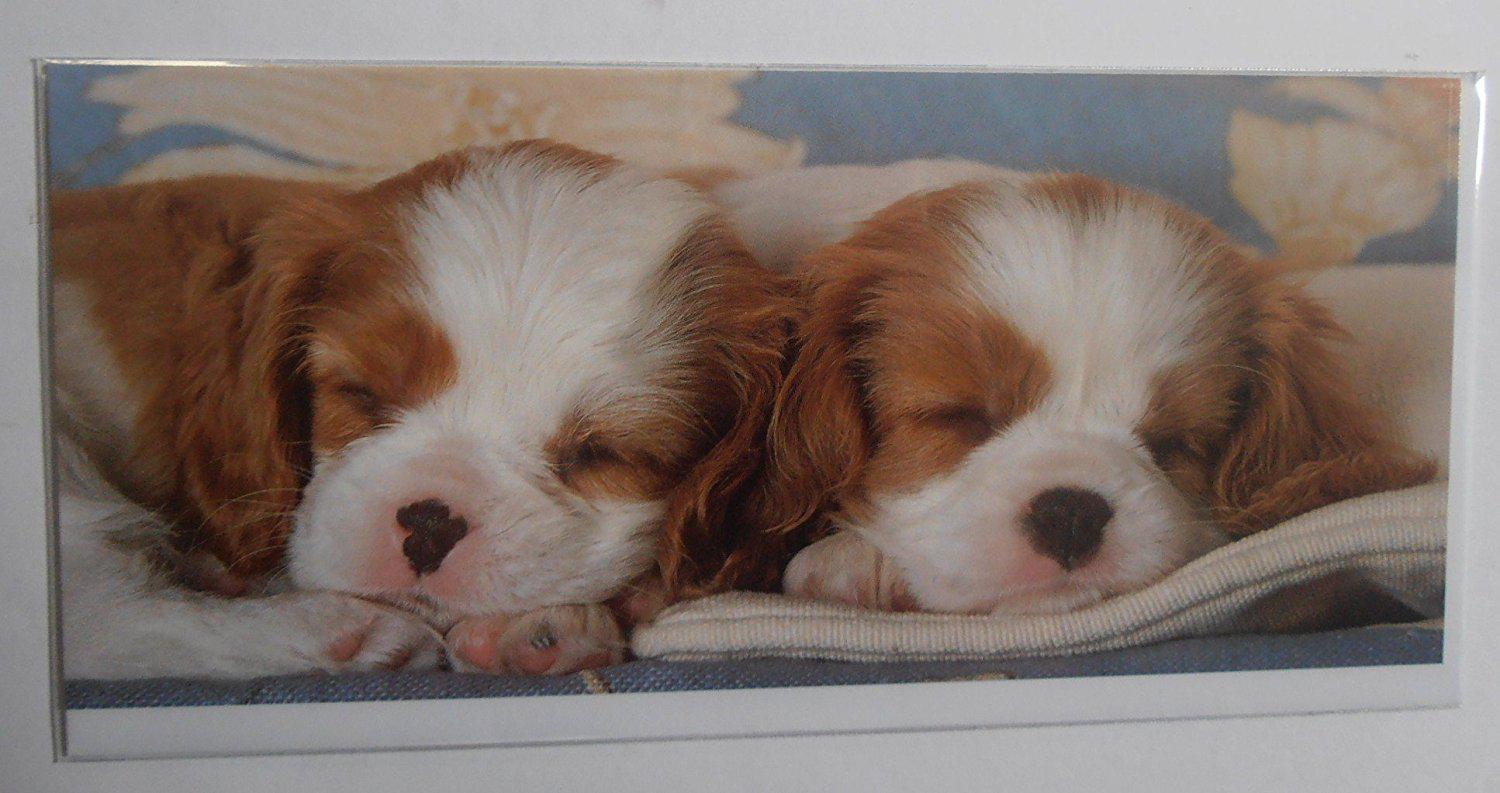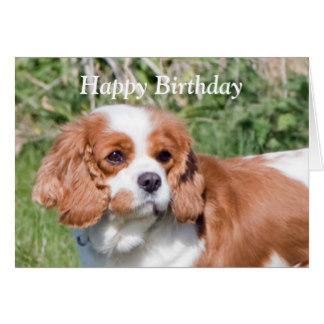The first image is the image on the left, the second image is the image on the right. Considering the images on both sides, is "A birthday hat has been placed on at least one puppy's head." valid? Answer yes or no. No. The first image is the image on the left, the second image is the image on the right. Analyze the images presented: Is the assertion "at least one dog in the image pair is wearing a party hat" valid? Answer yes or no. No. 